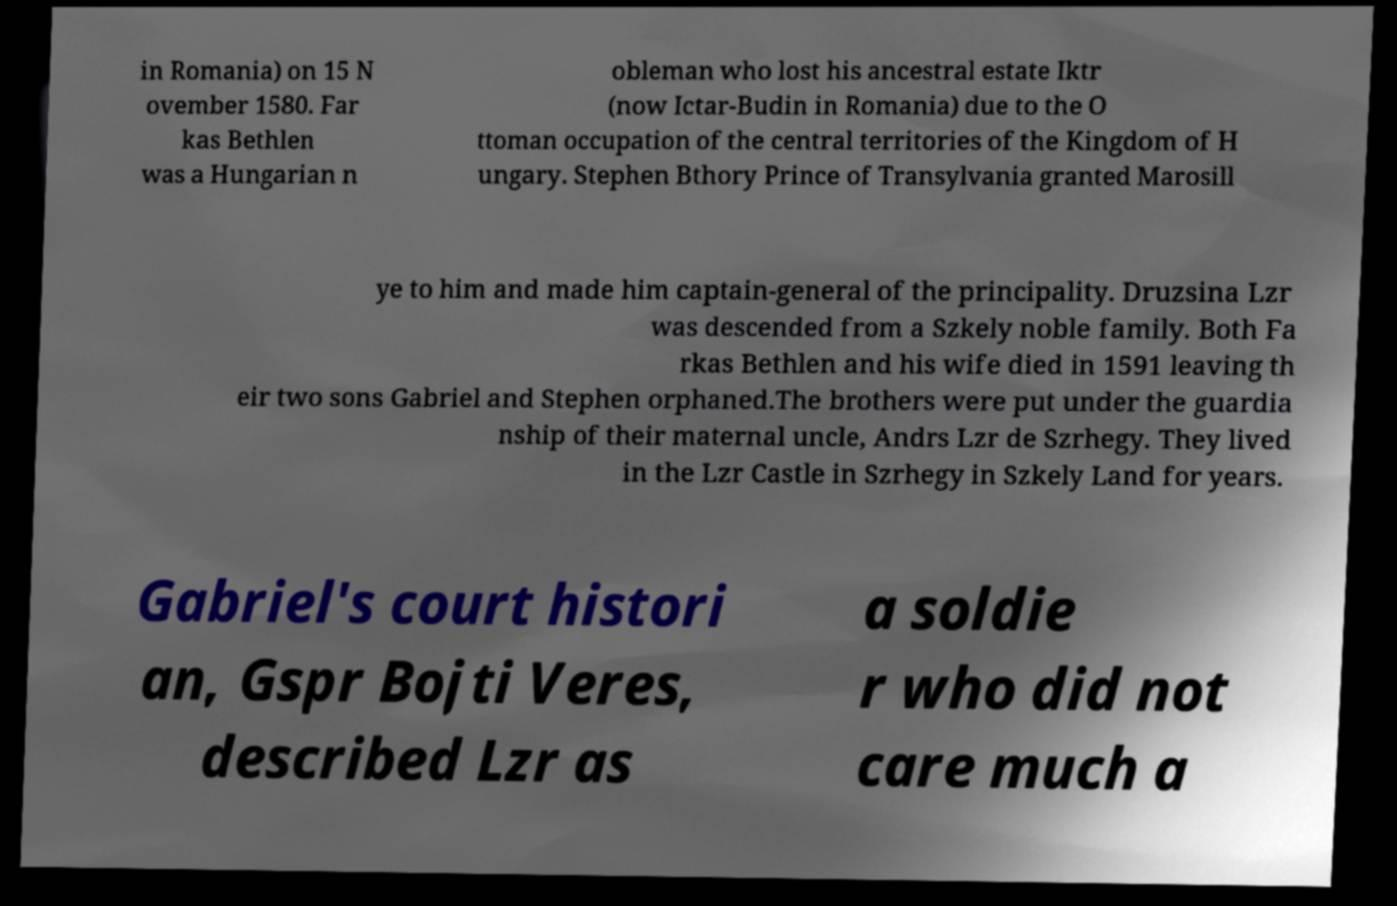For documentation purposes, I need the text within this image transcribed. Could you provide that? in Romania) on 15 N ovember 1580. Far kas Bethlen was a Hungarian n obleman who lost his ancestral estate Iktr (now Ictar-Budin in Romania) due to the O ttoman occupation of the central territories of the Kingdom of H ungary. Stephen Bthory Prince of Transylvania granted Marosill ye to him and made him captain-general of the principality. Druzsina Lzr was descended from a Szkely noble family. Both Fa rkas Bethlen and his wife died in 1591 leaving th eir two sons Gabriel and Stephen orphaned.The brothers were put under the guardia nship of their maternal uncle, Andrs Lzr de Szrhegy. They lived in the Lzr Castle in Szrhegy in Szkely Land for years. Gabriel's court histori an, Gspr Bojti Veres, described Lzr as a soldie r who did not care much a 